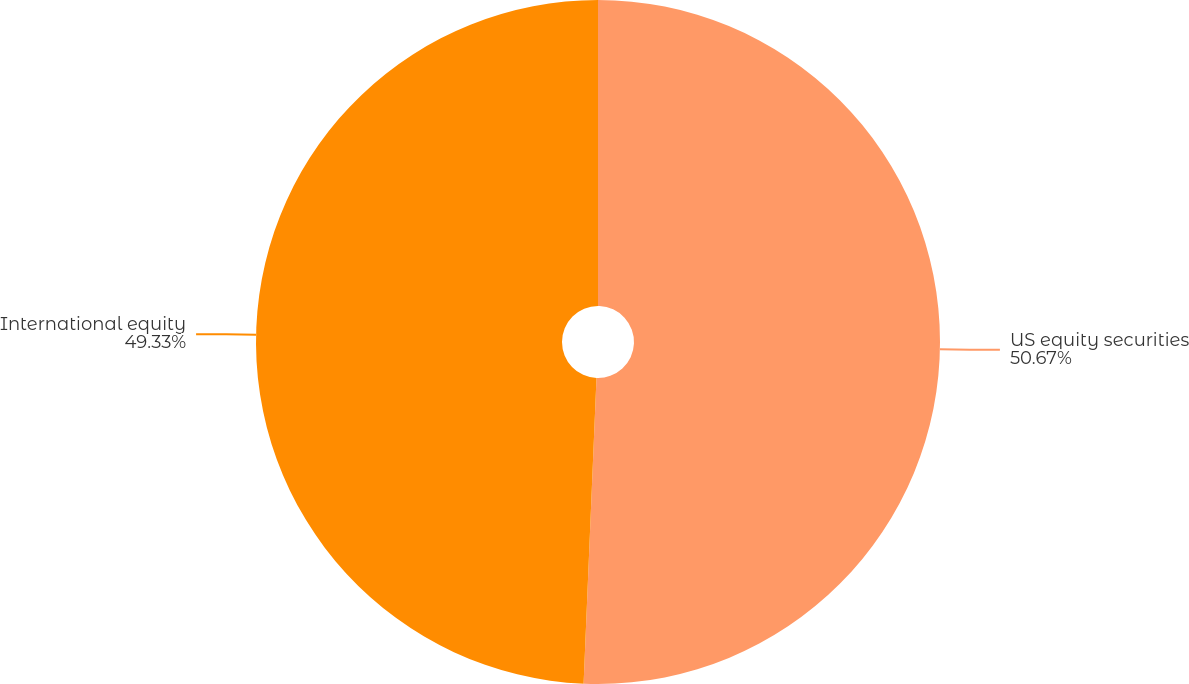Convert chart. <chart><loc_0><loc_0><loc_500><loc_500><pie_chart><fcel>US equity securities<fcel>International equity<nl><fcel>50.67%<fcel>49.33%<nl></chart> 